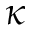Convert formula to latex. <formula><loc_0><loc_0><loc_500><loc_500>\kappa</formula> 